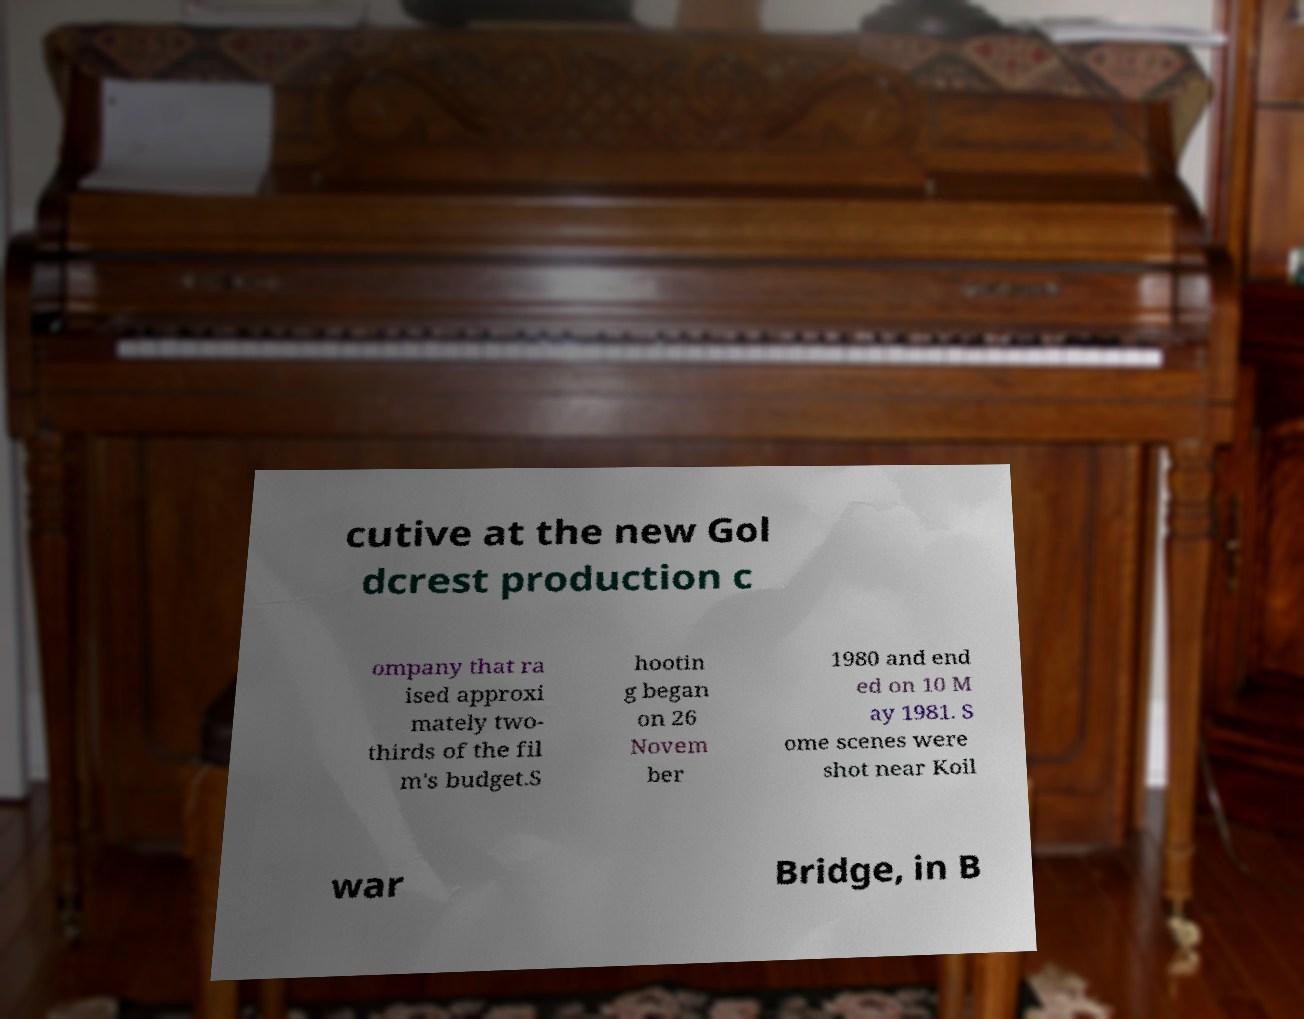I need the written content from this picture converted into text. Can you do that? cutive at the new Gol dcrest production c ompany that ra ised approxi mately two- thirds of the fil m's budget.S hootin g began on 26 Novem ber 1980 and end ed on 10 M ay 1981. S ome scenes were shot near Koil war Bridge, in B 